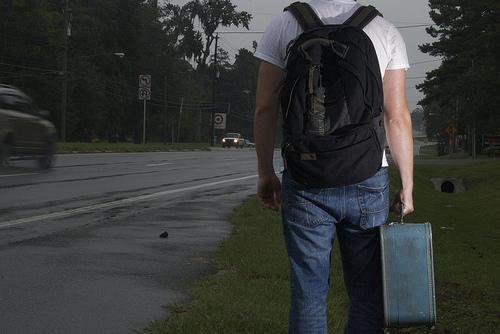How many cars are there?
Give a very brief answer. 2. 